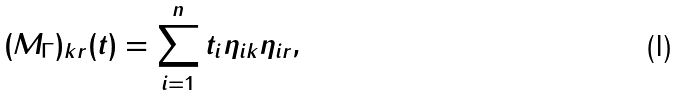Convert formula to latex. <formula><loc_0><loc_0><loc_500><loc_500>( M _ { \Gamma } ) _ { k r } ( t ) = \sum _ { i = 1 } ^ { n } t _ { i } \eta _ { i k } \eta _ { i r } ,</formula> 